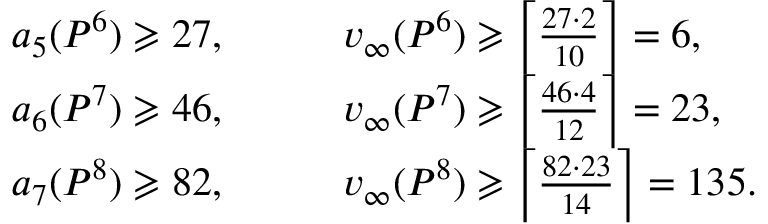Convert formula to latex. <formula><loc_0><loc_0><loc_500><loc_500>\begin{array} { r l } { a _ { 5 } ( P ^ { 6 } ) \geqslant 2 7 , \quad } & { v _ { \infty } ( P ^ { 6 } ) \geqslant \left \lceil \frac { 2 7 \cdot 2 } { 1 0 } \right \rceil = 6 , } \\ { a _ { 6 } ( P ^ { 7 } ) \geqslant 4 6 , \quad } & { v _ { \infty } ( P ^ { 7 } ) \geqslant \left \lceil \frac { 4 6 \cdot 4 } { 1 2 } \right \rceil = 2 3 , } \\ { a _ { 7 } ( P ^ { 8 } ) \geqslant 8 2 , \quad } & { v _ { \infty } ( P ^ { 8 } ) \geqslant \left \lceil \frac { 8 2 \cdot 2 3 } { 1 4 } \right \rceil = 1 3 5 . } \end{array}</formula> 